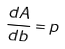<formula> <loc_0><loc_0><loc_500><loc_500>\frac { d A } { d b } = p</formula> 